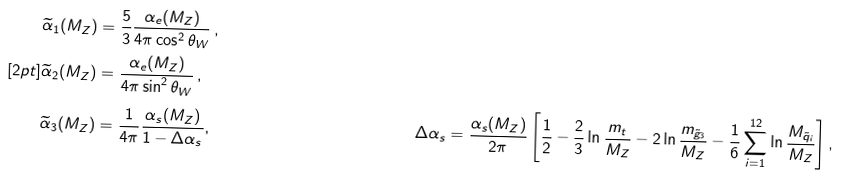<formula> <loc_0><loc_0><loc_500><loc_500>\widetilde { \alpha } _ { 1 } ( M _ { Z } ) & = \frac { 5 } { 3 } \frac { \alpha _ { e } ( M _ { Z } ) } { 4 \pi \cos ^ { 2 } \theta _ { W } } \, , \\ [ 2 p t ] \widetilde { \alpha } _ { 2 } ( M _ { Z } ) & = \frac { \alpha _ { e } ( M _ { Z } ) } { 4 \pi \sin ^ { 2 } \theta _ { W } } \, , \\ \widetilde { \alpha } _ { 3 } ( M _ { Z } ) & = \frac { 1 } { 4 \pi } \frac { \alpha _ { s } ( M _ { Z } ) } { 1 - \Delta \alpha _ { s } } , & \Delta \alpha _ { s } & = \frac { \alpha _ { s } ( M _ { Z } ) } { 2 \pi } \left [ \frac { 1 } { 2 } - \frac { 2 } { 3 } \ln \frac { m _ { t } } { M _ { Z } } - 2 \ln \frac { m _ { \tilde { g } _ { 3 } } } { M _ { Z } } - \frac { 1 } { 6 } \sum _ { i = 1 } ^ { 1 2 } \ln \frac { M _ { \tilde { q } _ { i } } } { M _ { Z } } \right ] ,</formula> 